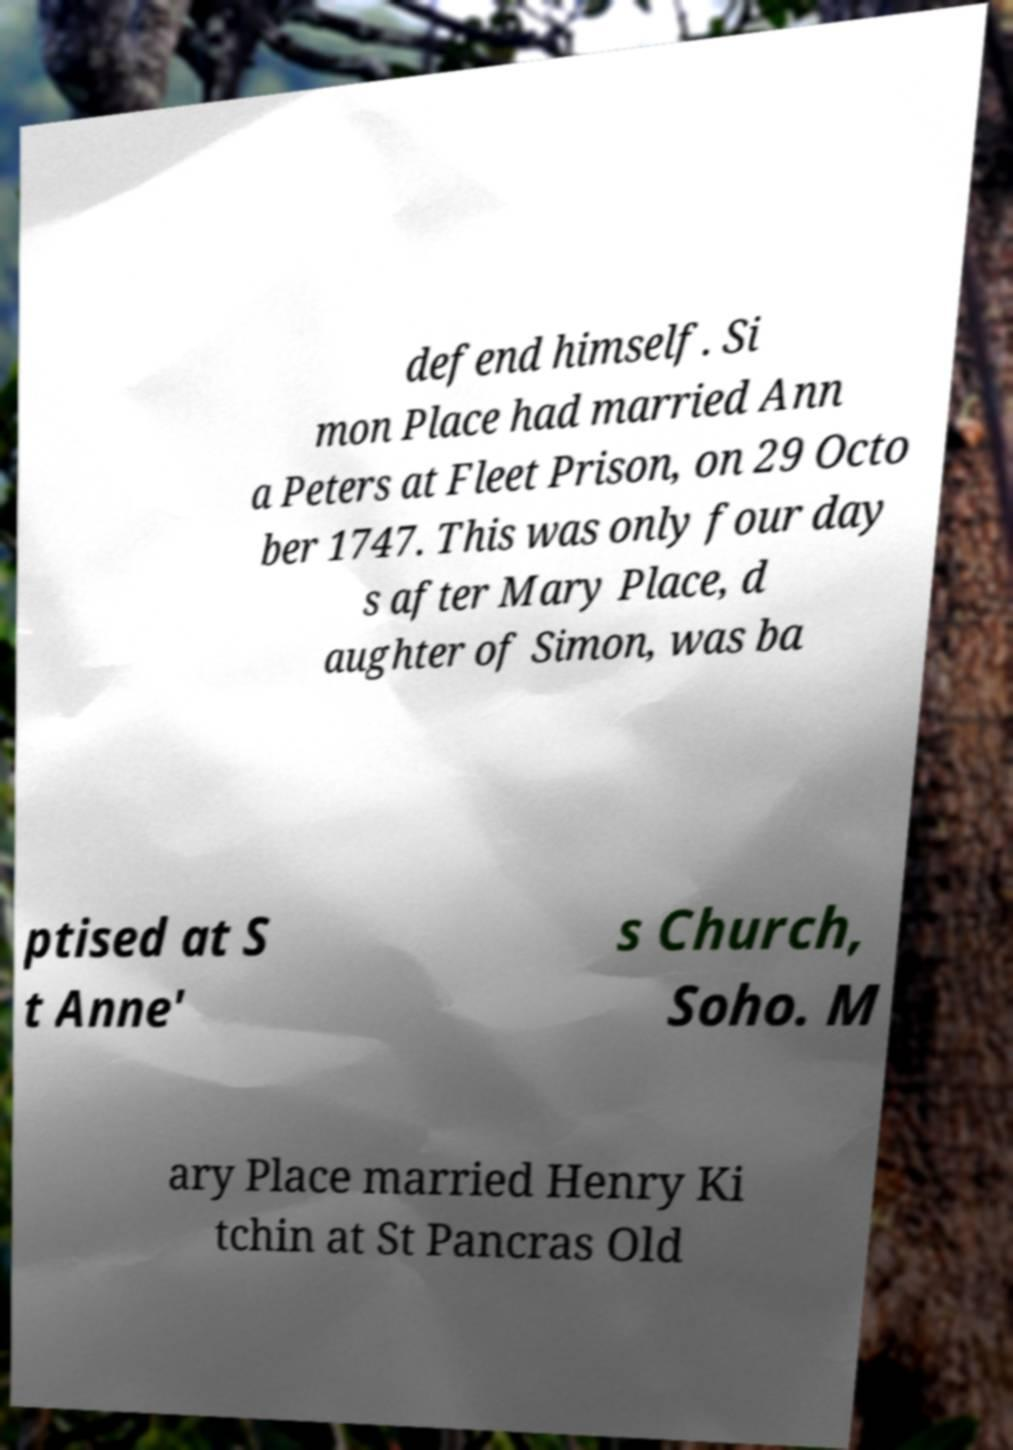Please read and relay the text visible in this image. What does it say? defend himself. Si mon Place had married Ann a Peters at Fleet Prison, on 29 Octo ber 1747. This was only four day s after Mary Place, d aughter of Simon, was ba ptised at S t Anne' s Church, Soho. M ary Place married Henry Ki tchin at St Pancras Old 